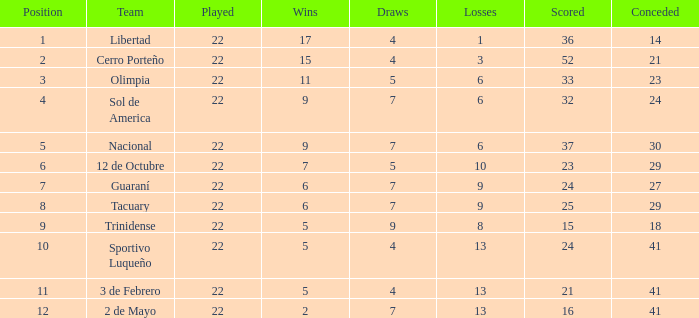What is the least number of wins having below 23 goals scored, 2 de mayo squad, and fewer than 7 ties? None. 